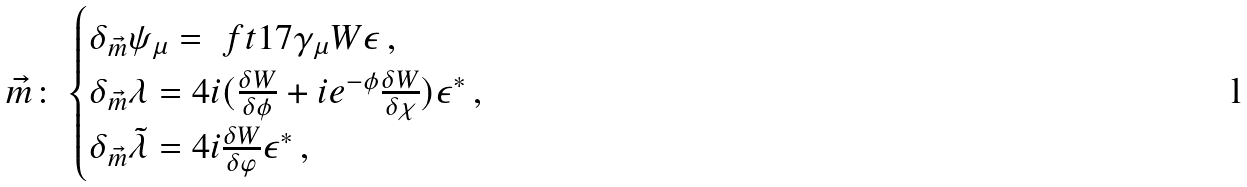<formula> <loc_0><loc_0><loc_500><loc_500>\vec { m } \colon & \begin{cases} \delta _ { \vec { m } } \psi _ { \mu } = \ f t { 1 } { 7 } \gamma _ { \mu } W \epsilon \, , \\ \delta _ { \vec { m } } \lambda = 4 i ( \frac { \delta W } { \delta \phi } + i e ^ { - \phi } \frac { \delta W } { \delta \chi } ) \epsilon ^ { * } \, , \\ \delta _ { \vec { m } } \tilde { \lambda } = 4 i \frac { \delta W } { \delta \varphi } \epsilon ^ { * } \, , \end{cases}</formula> 